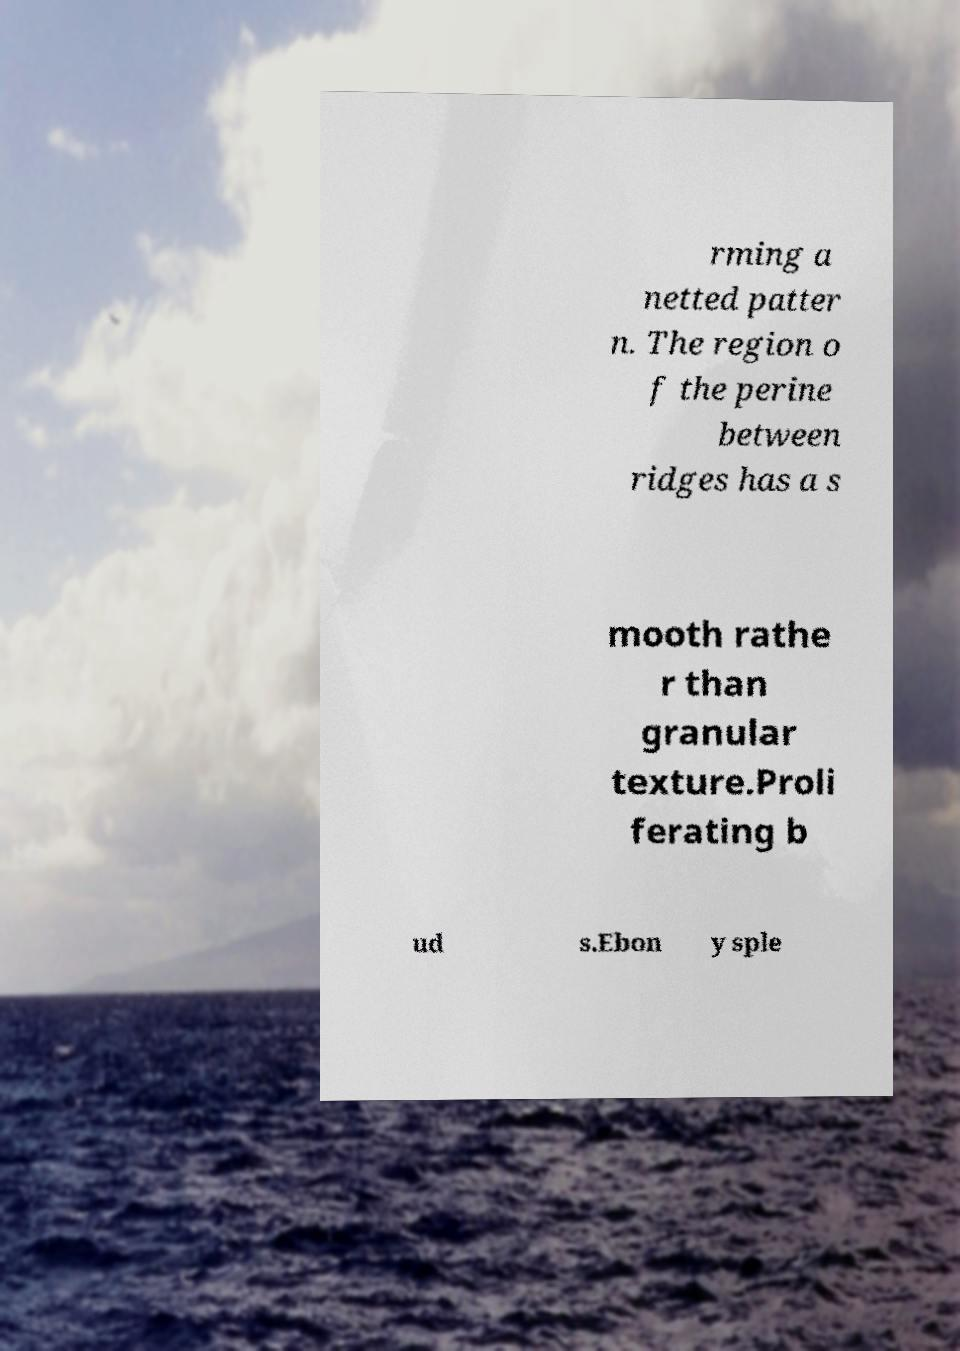Could you assist in decoding the text presented in this image and type it out clearly? rming a netted patter n. The region o f the perine between ridges has a s mooth rathe r than granular texture.Proli ferating b ud s.Ebon y sple 